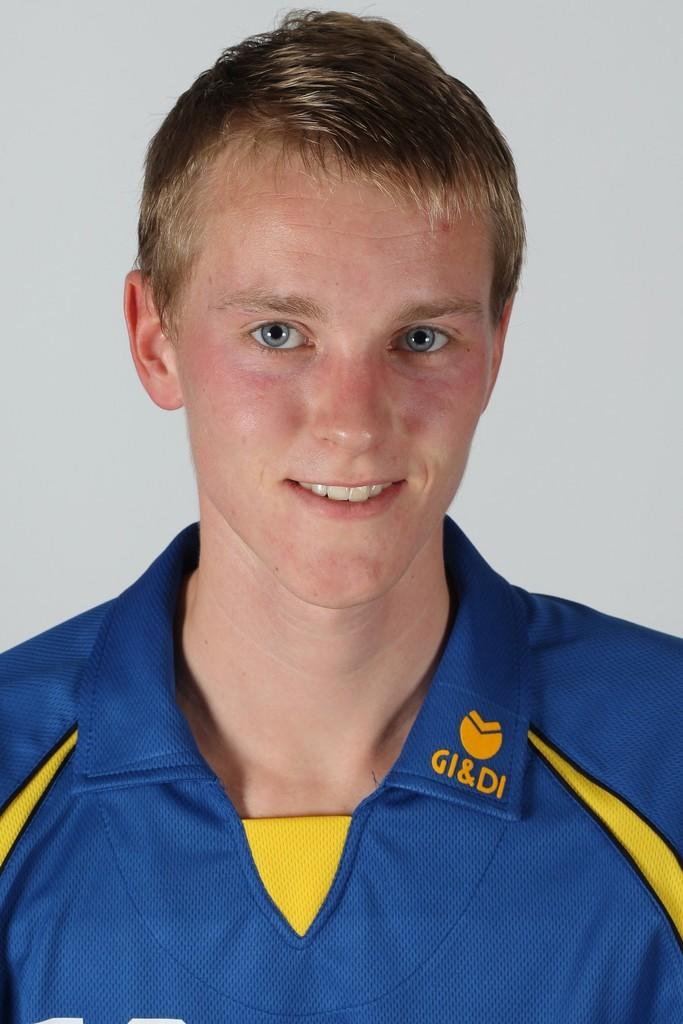<image>
Present a compact description of the photo's key features. A blond man wearing a shirt that says GI & DI on the collar. 